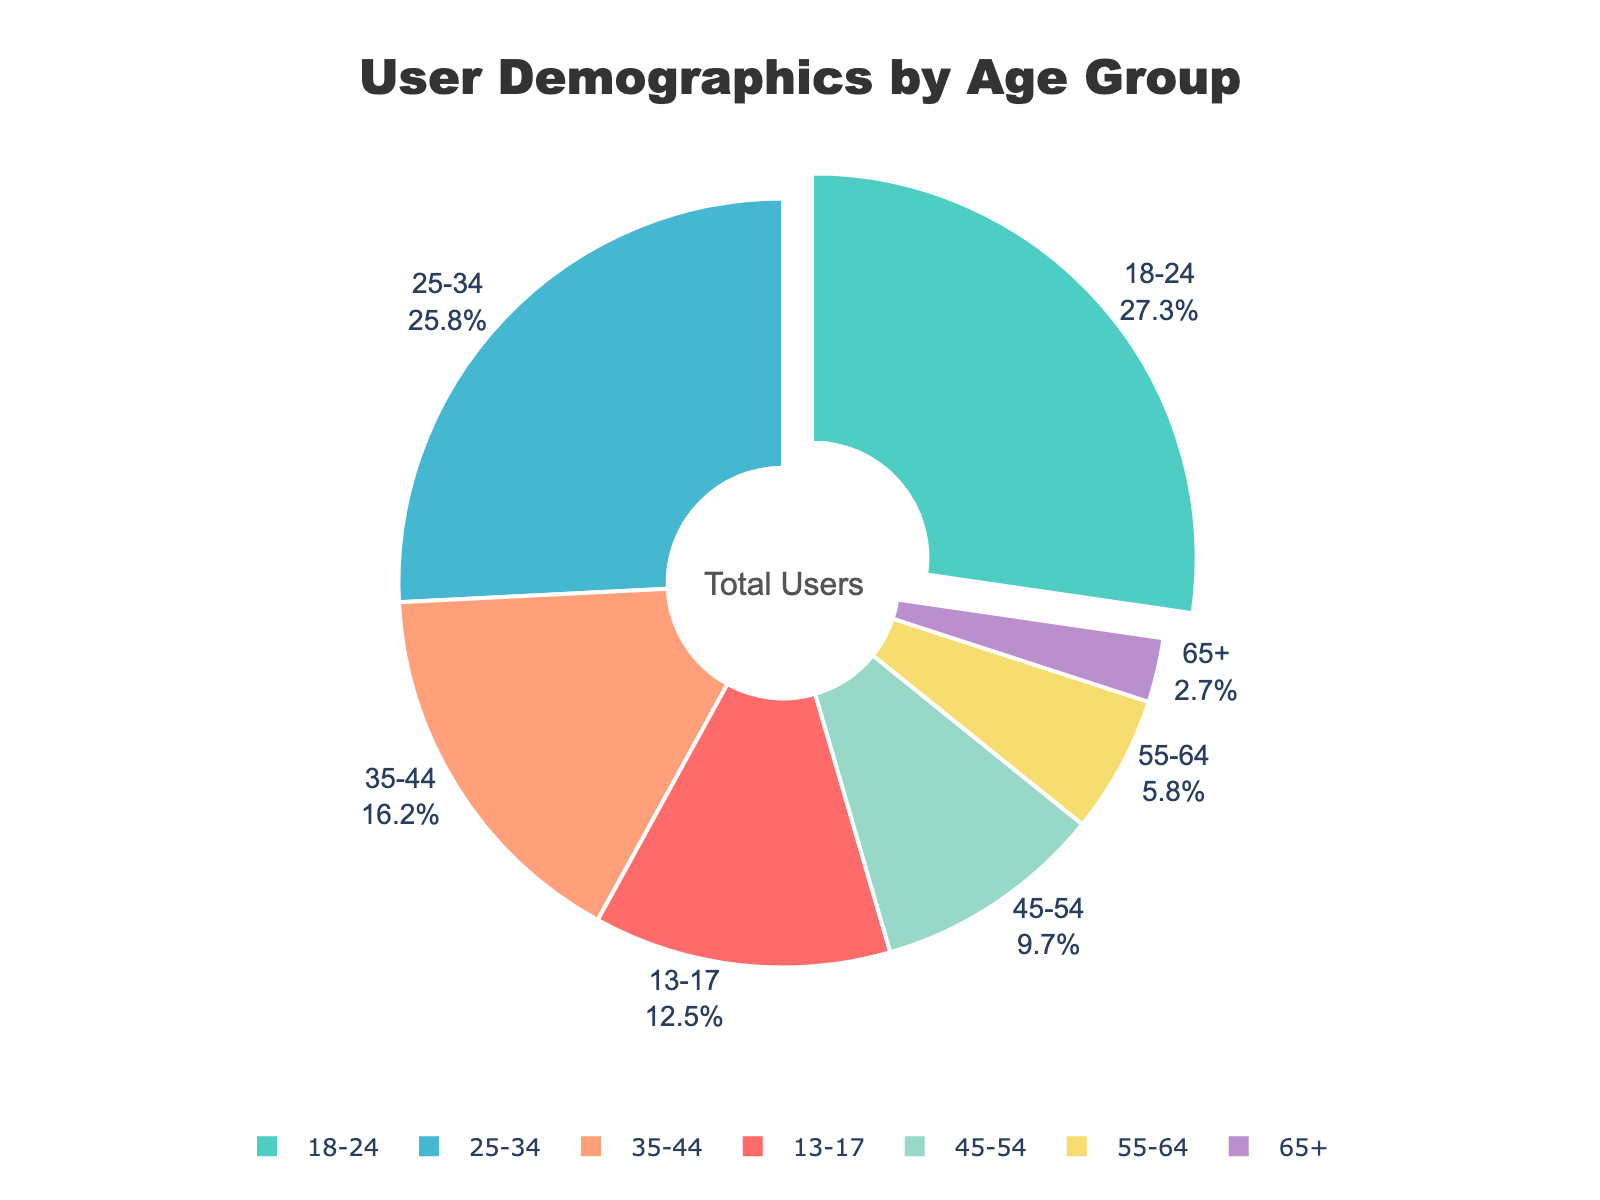What percentage of users are aged between 18 and 34? Add the percentages of the 18-24 and 25-34 age groups: 27.3% + 25.8% = 53.1%
Answer: 53.1% Which age group has the smallest representation? The age group with the smallest percentage is 65+, with 2.7%.
Answer: 65+ Which age group's slice of the pie chart is pulled out slightly? The slice pulled out slightly is the one with the highest percentage, which is the 18-24 age group at 27.3%.
Answer: 18-24 What is the combined percentage of users aged 35 and above? Add the percentages of the 35-44, 45-54, 55-64, and 65+ age groups: 16.2% + 9.7% + 5.8% + 2.7% = 34.4%
Answer: 34.4% Compare the percentage of users aged 25-34 to those aged 45-54. The percentage of users aged 25-34 is 25.8%, which is much higher than the 9.7% of users aged 45-54.
Answer: 25-34 is higher What is the difference in percentages between the age groups 13-17 and 55-64? Subtract the percentage of the 55-64 age group from the 13-17 age group: 12.5% - 5.8% = 6.7%
Answer: 6.7% What proportion of the pie chart is represented by users aged under 18 and over 45 combined? Add the percentages of the 13-17, 45-54, 55-64, and 65+ age groups: 12.5% + 9.7% + 5.8% + 2.7% = 30.7%
Answer: 30.7% Which age group has a percentage closest to the average percentage of all age groups? Calculate the average of all age groups: (12.5% + 27.3% + 25.8% + 16.2% + 9.7% + 5.8% + 2.7%) / 7 = 14.29%. The closest group is the 16.2% of ages 35-44.
Answer: 35-44 